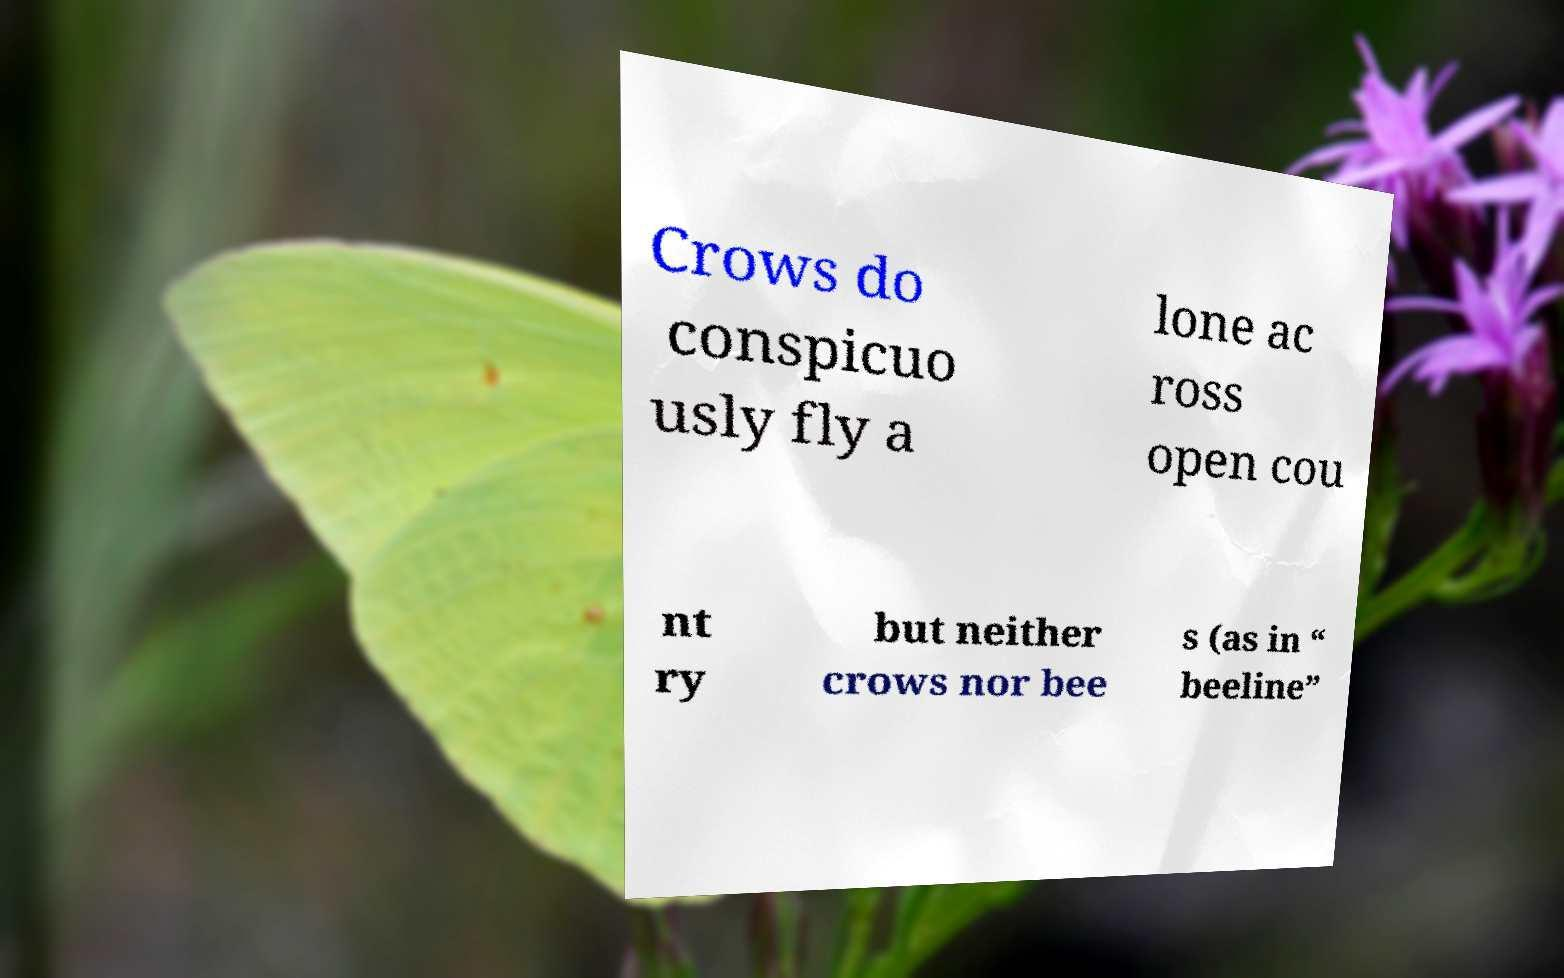Can you accurately transcribe the text from the provided image for me? Crows do conspicuo usly fly a lone ac ross open cou nt ry but neither crows nor bee s (as in “ beeline” 